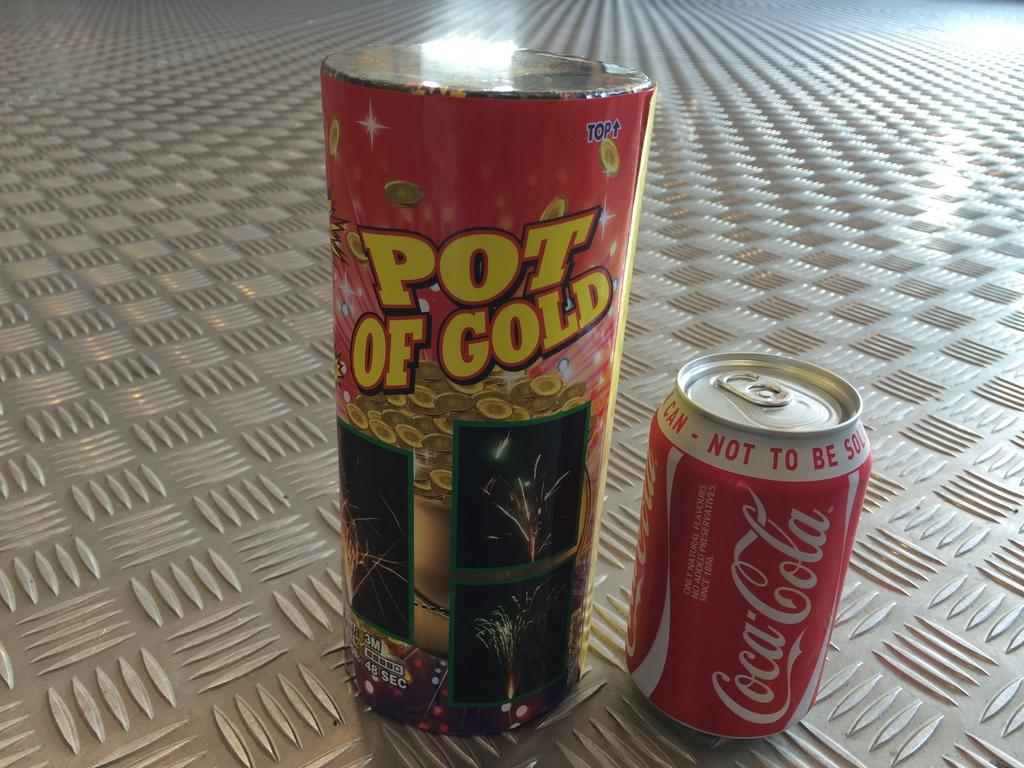<image>
Create a compact narrative representing the image presented. A container of Pot of Gold beside a can of Coca-Cola. 